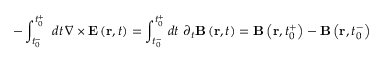<formula> <loc_0><loc_0><loc_500><loc_500>- \int _ { t _ { 0 } ^ { - } } ^ { t _ { 0 } ^ { + } } \, d t \, \nabla \times E \left ( r , t \right ) = \int _ { t _ { 0 } ^ { - } } ^ { t _ { 0 } ^ { + } } d t \, \partial _ { t } B \left ( r , t \right ) = B \left ( r , t _ { 0 } ^ { + } \right ) - B \left ( r , t _ { 0 } ^ { - } \right )</formula> 